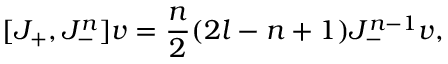<formula> <loc_0><loc_0><loc_500><loc_500>[ J _ { + } , J _ { - } ^ { n } ] v = { \frac { n } { 2 } } ( 2 l - n + 1 ) J _ { - } ^ { n - 1 } v ,</formula> 